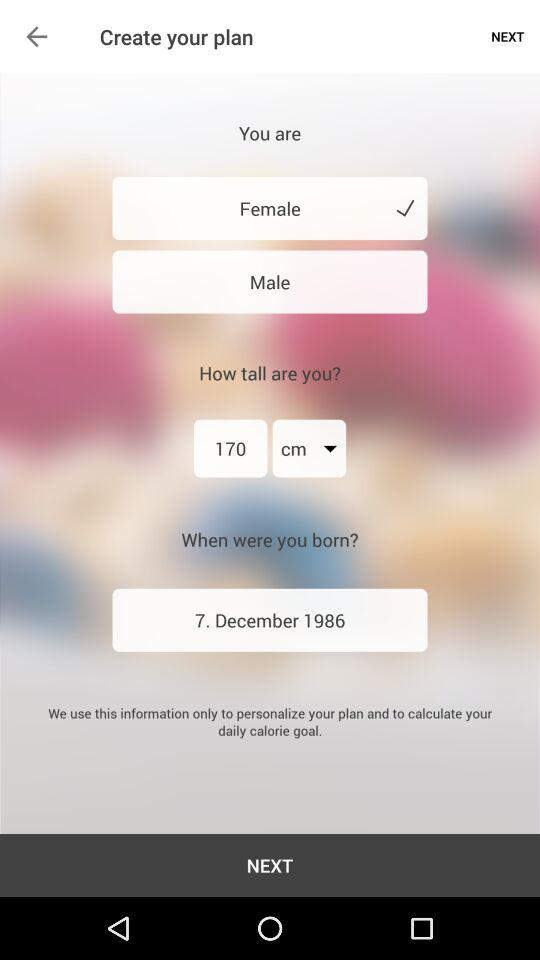How many centimeters tall is the user?
Answer the question using a single word or phrase. 170 